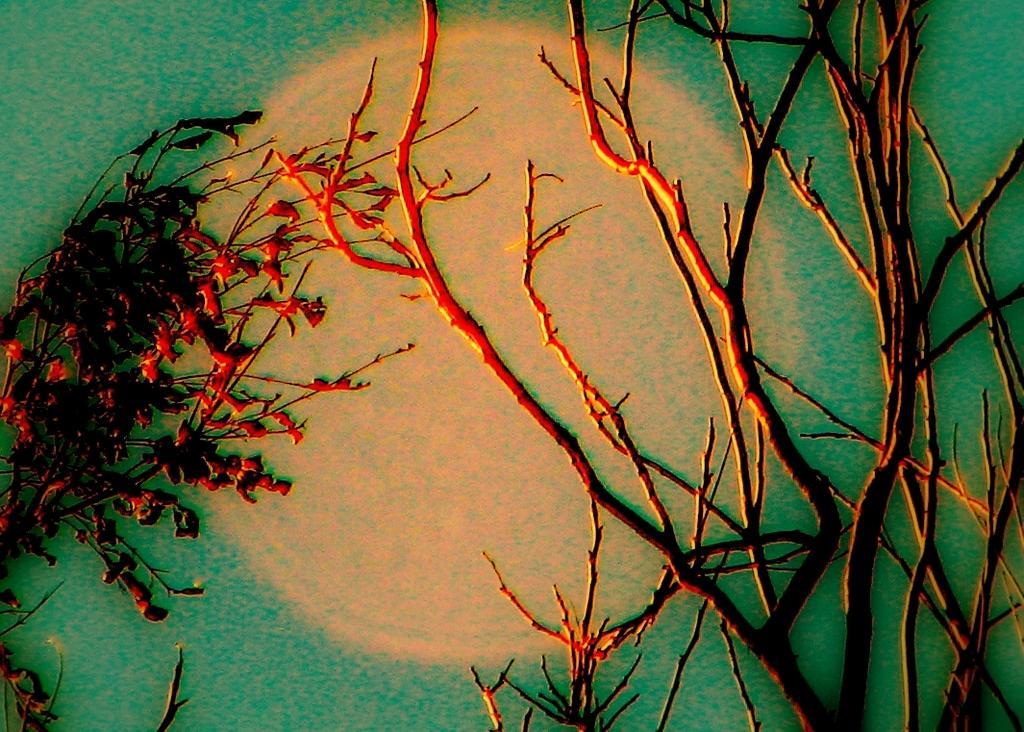Describe this image in one or two sentences. This is a painting where we can see the trees, the sky and the moon. 